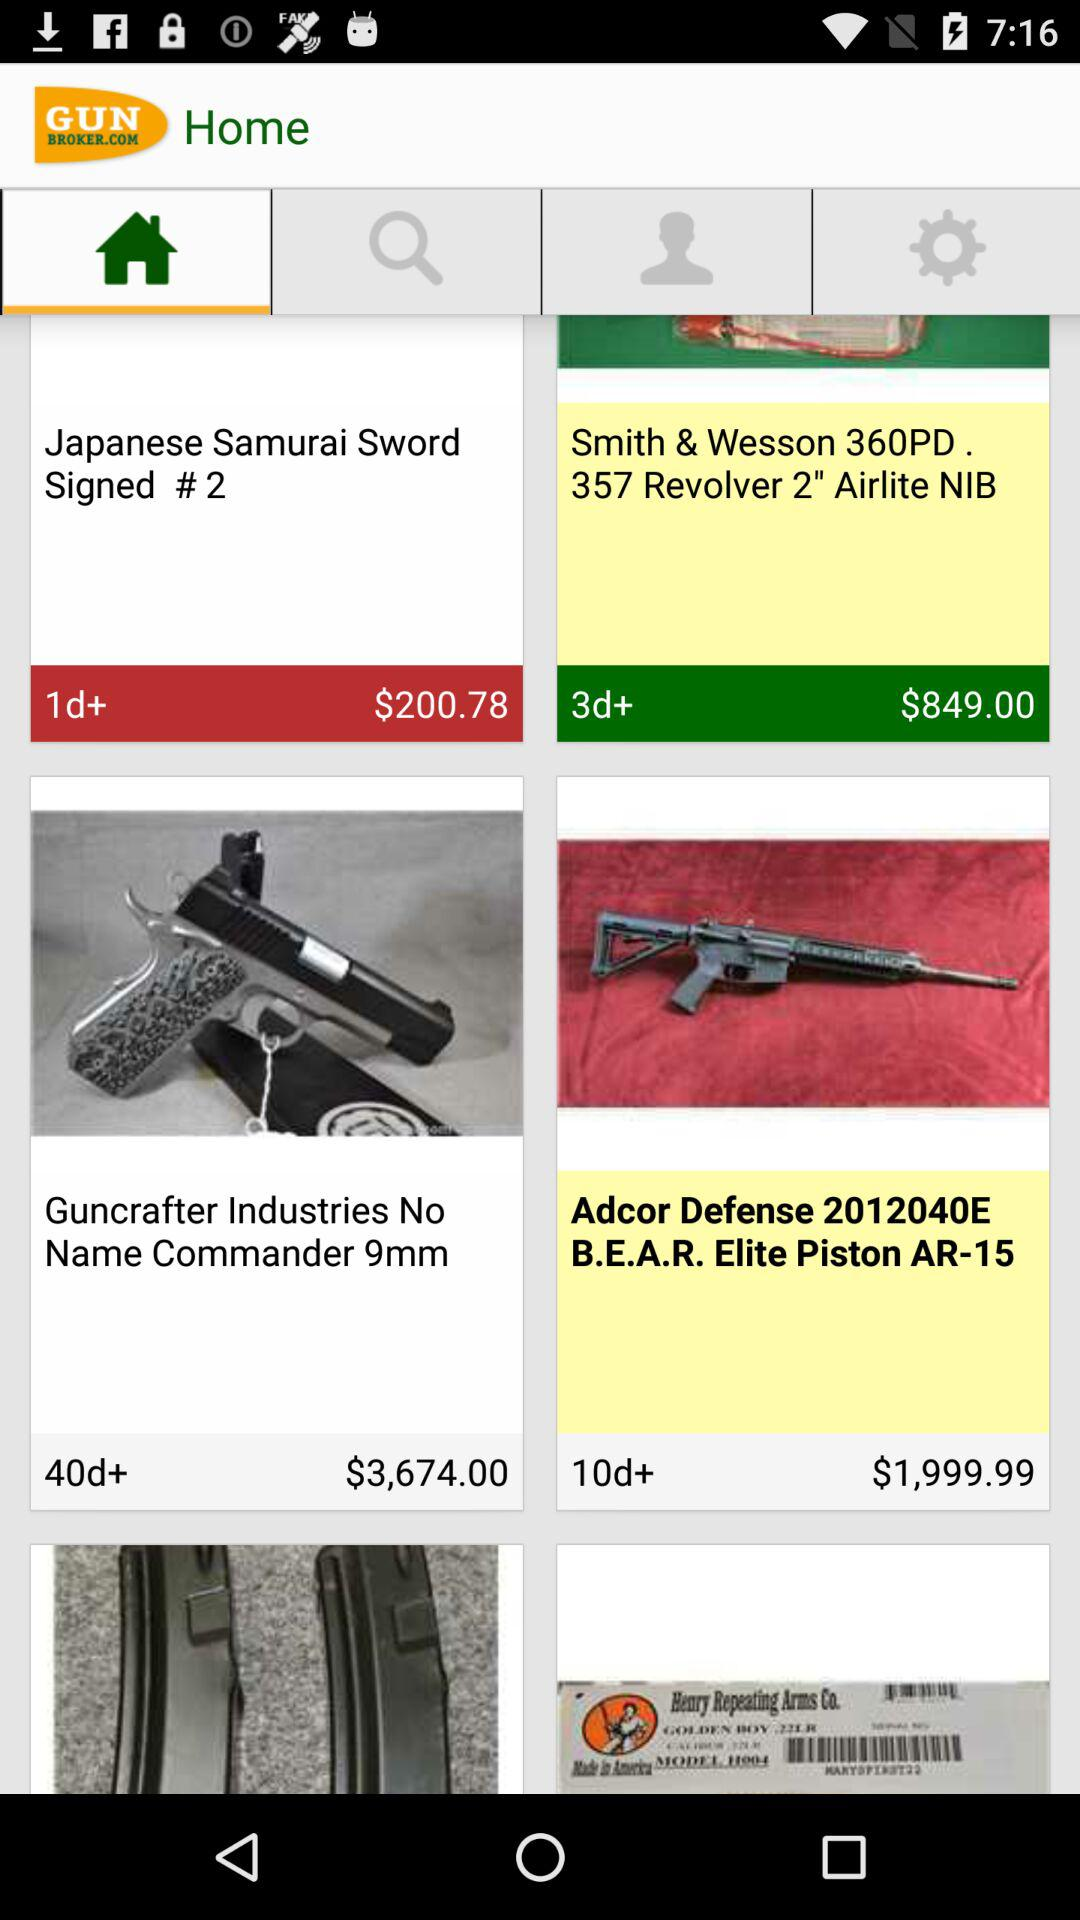What is the application name? The application name is "GunBroker.com". 